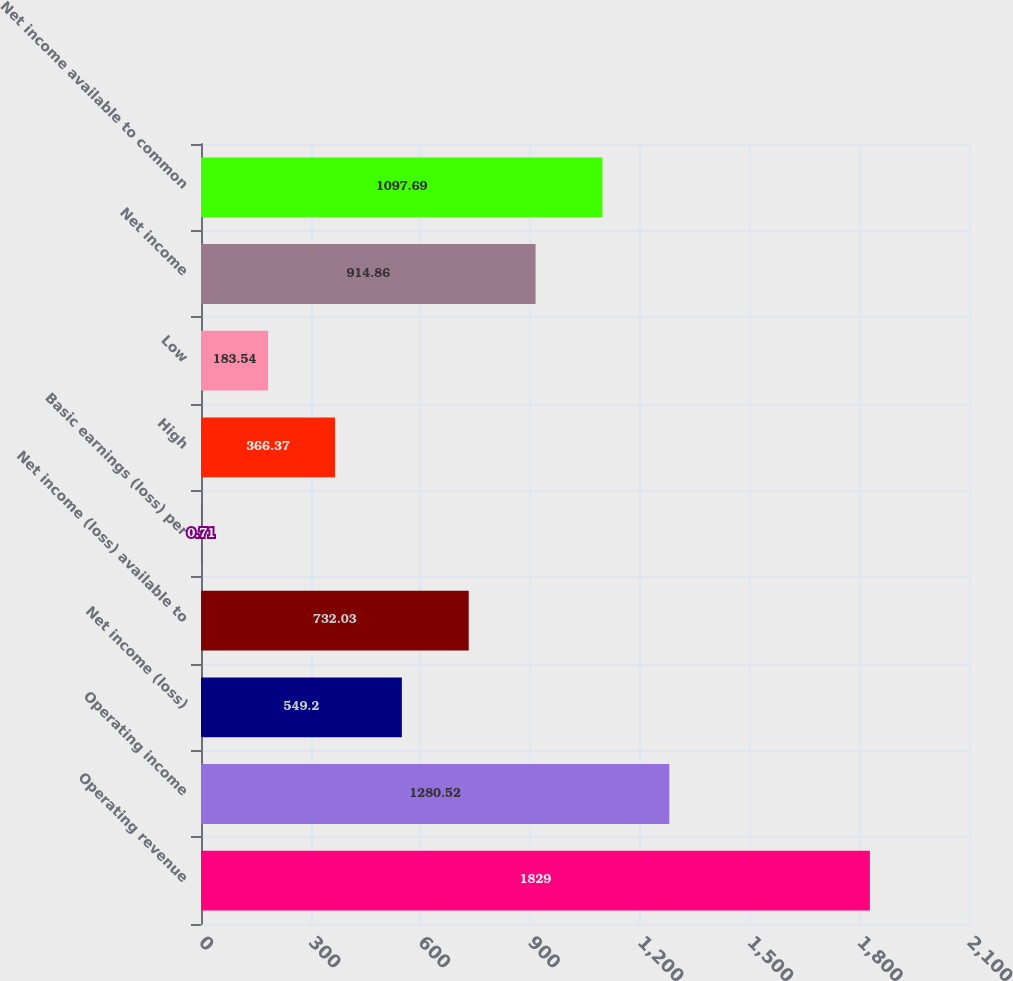<chart> <loc_0><loc_0><loc_500><loc_500><bar_chart><fcel>Operating revenue<fcel>Operating income<fcel>Net income (loss)<fcel>Net income (loss) available to<fcel>Basic earnings (loss) per<fcel>High<fcel>Low<fcel>Net income<fcel>Net income available to common<nl><fcel>1829<fcel>1280.52<fcel>549.2<fcel>732.03<fcel>0.71<fcel>366.37<fcel>183.54<fcel>914.86<fcel>1097.69<nl></chart> 